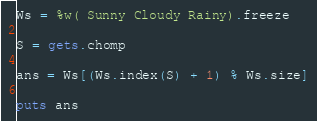<code> <loc_0><loc_0><loc_500><loc_500><_Ruby_>Ws = %w( Sunny Cloudy Rainy).freeze

S = gets.chomp

ans = Ws[(Ws.index(S) + 1) % Ws.size]

puts ans
</code> 